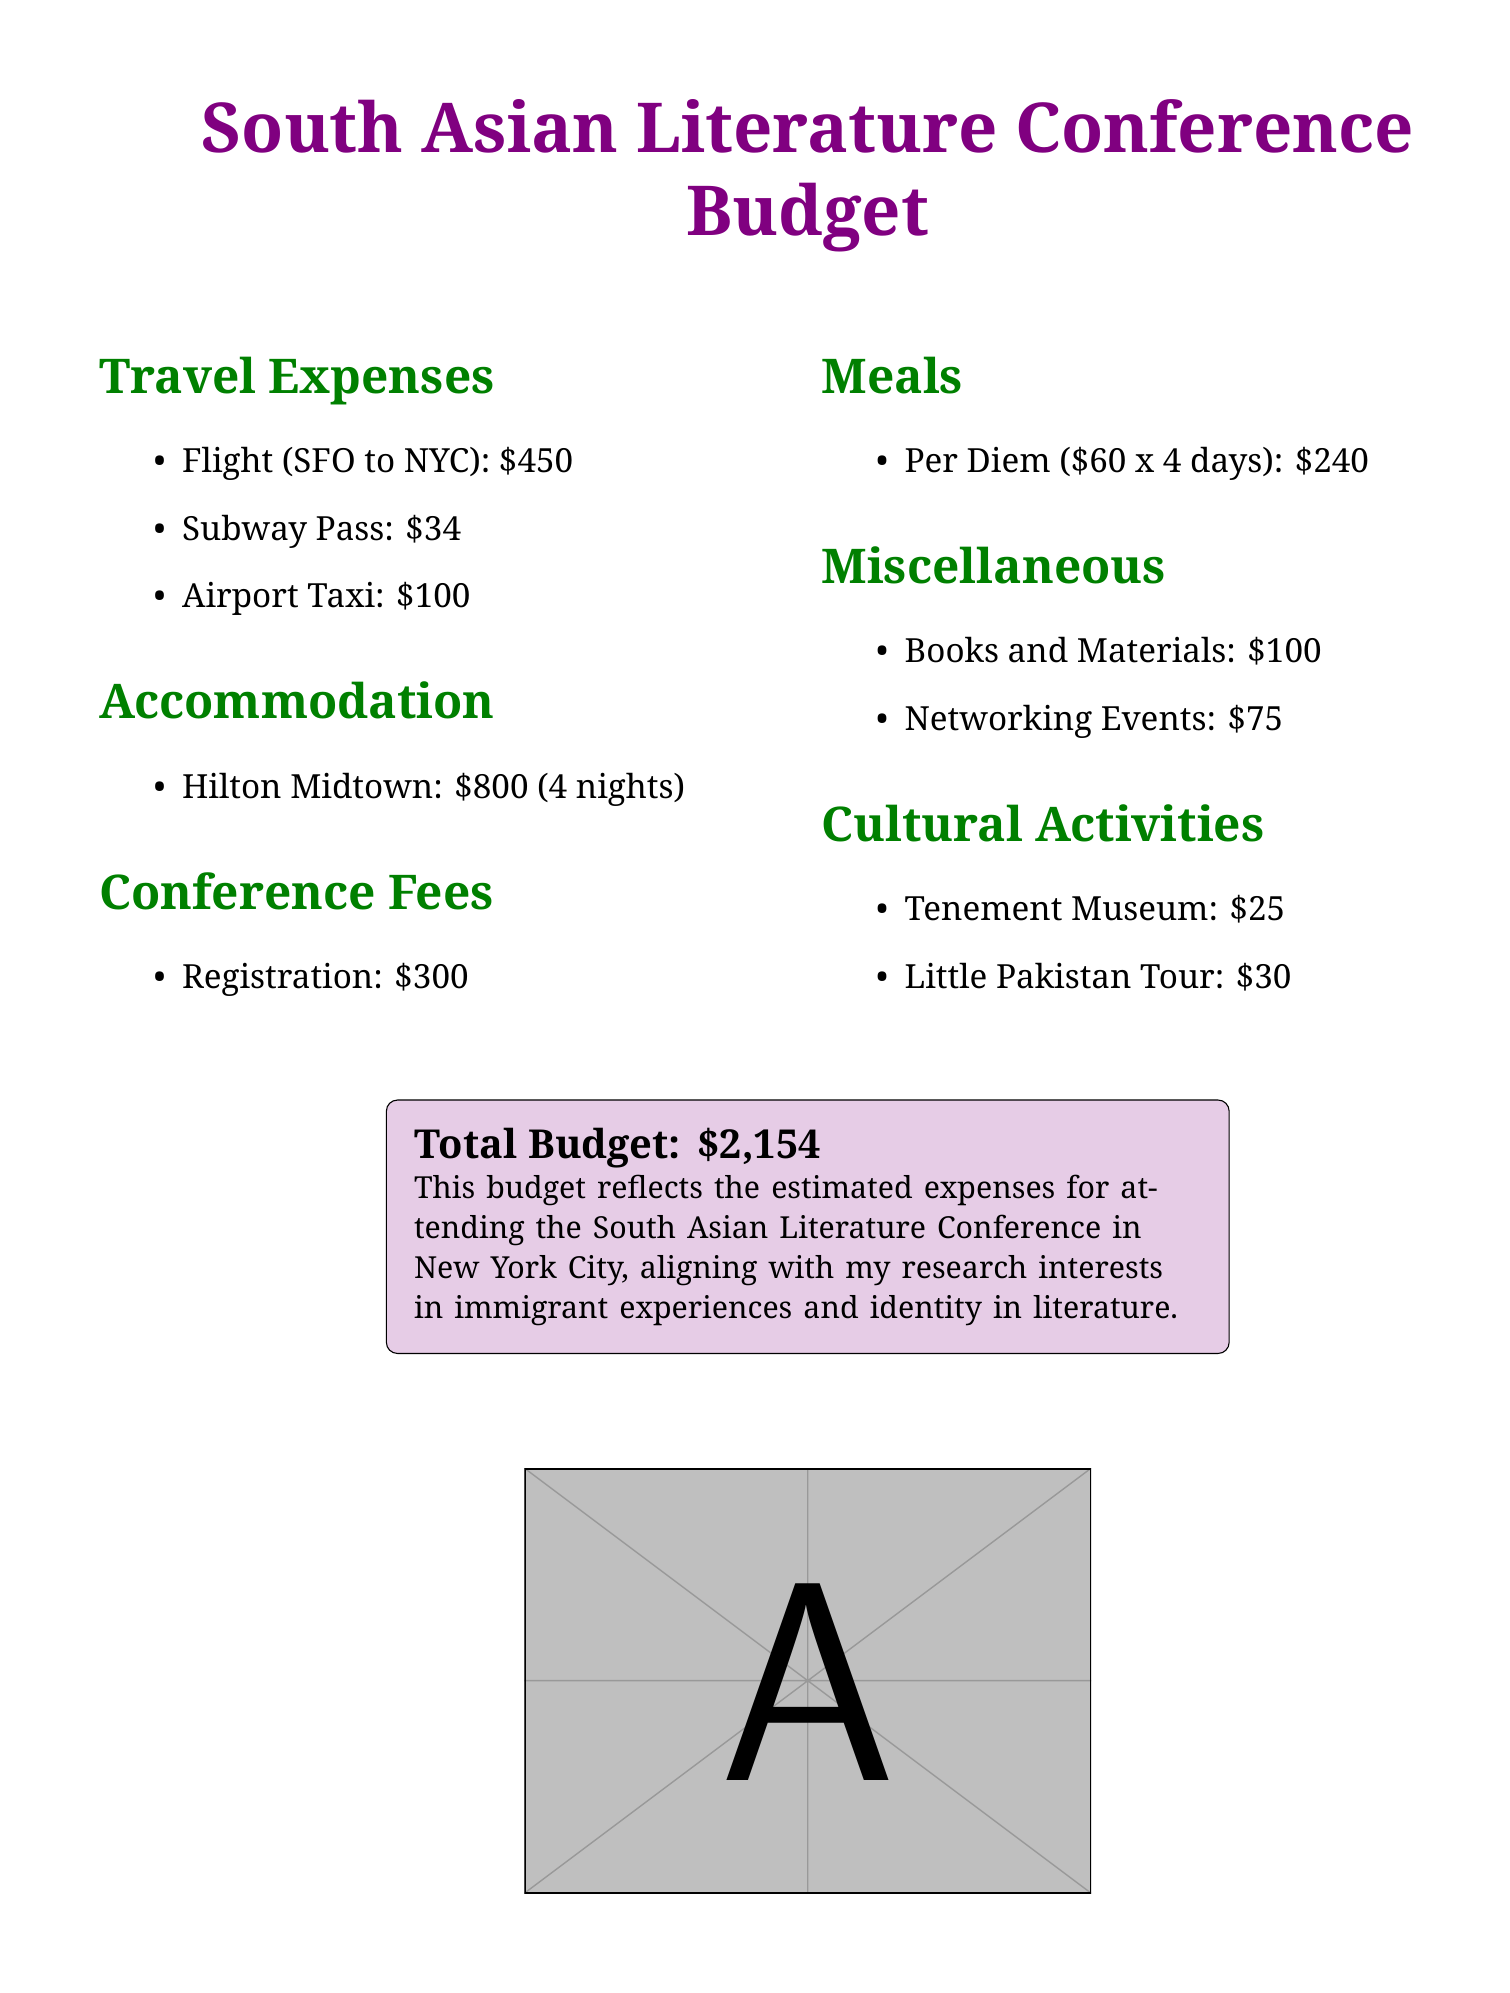What is the total budget? The total budget is explicitly mentioned at the bottom of the document as $2,154.
Answer: $2,154 What is the cost of a flight from SFO to NYC? The document lists the flight expense as $450.
Answer: $450 How much will meals cost for four days? Meals are calculated at a per diem of $60 for 4 days, totaling $240.
Answer: $240 What are the accommodation expenses for the conference? The document states the accommodation cost for Hilton Midtown over 4 nights is $800.
Answer: $800 What is the registration fee for the conference? The registration fee is specifically mentioned as $300 in the document.
Answer: $300 How much is allocated for networking events? Networking events are listed with a budget of $75 in the miscellaneous section.
Answer: $75 What is the cost for cultural activities? The document outlines the costs for cultural activities as $55 total (Tenement Museum and Little Pakistan Tour).
Answer: $55 How much is the subway pass? The subway pass expense is detailed in the document as $34.
Answer: $34 What is the cost of the Airport Taxi? The document states that the Airport Taxi expense is $100.
Answer: $100 What activities does the budget include under cultural activities? The budget mentions the Tenement Museum and Little Pakistan Tour as cultural activities.
Answer: Tenement Museum and Little Pakistan Tour 